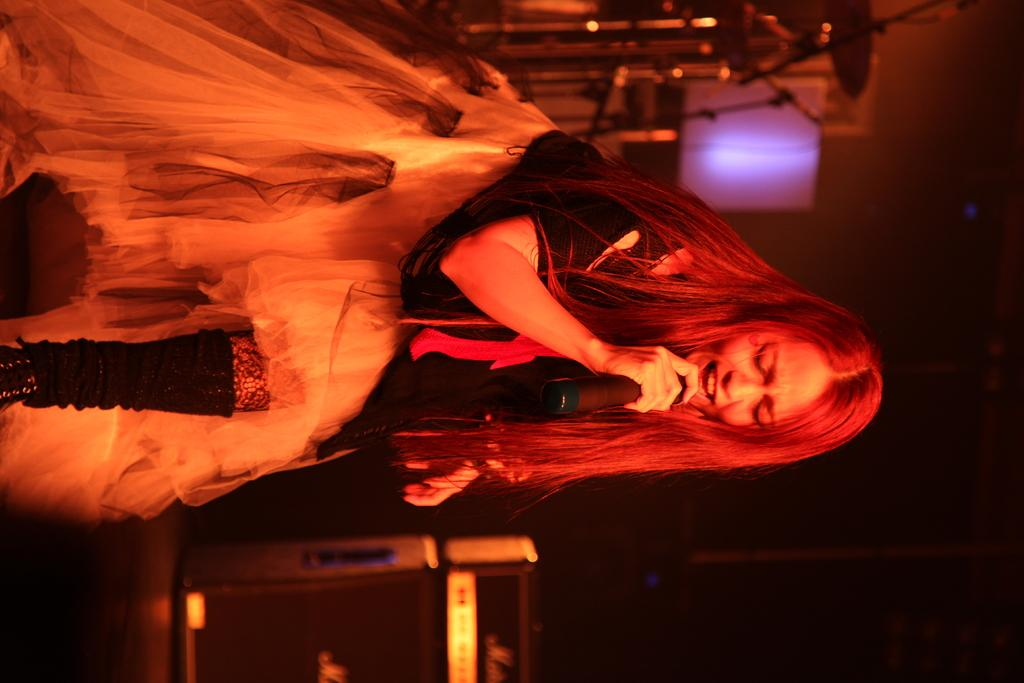Who is the main subject in the image? There is a woman in the image. What is the woman doing in the image? The woman is singing on a microphone. Are there any musical instruments present in the image? Yes, there are musical instruments in the image. What is the color of the background in the image? The background of the image is dark. What type of sweater is the woman wearing in the image? There is no sweater visible in the image; the woman is not wearing any clothing. Can you tell me how many mailboxes are present in the image? There are no mailboxes present in the image. 